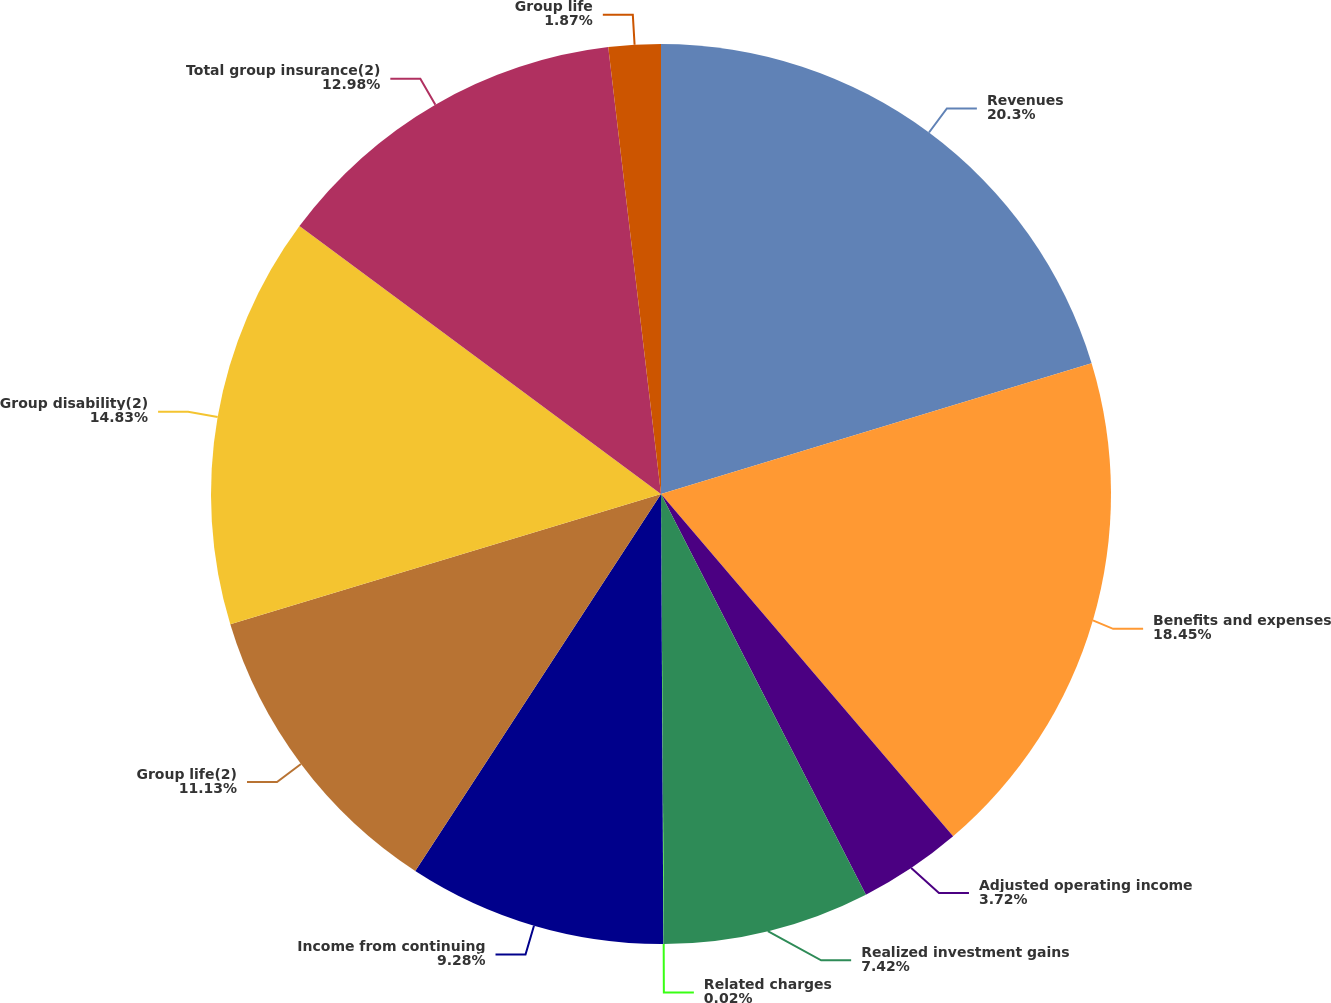Convert chart to OTSL. <chart><loc_0><loc_0><loc_500><loc_500><pie_chart><fcel>Revenues<fcel>Benefits and expenses<fcel>Adjusted operating income<fcel>Realized investment gains<fcel>Related charges<fcel>Income from continuing<fcel>Group life(2)<fcel>Group disability(2)<fcel>Total group insurance(2)<fcel>Group life<nl><fcel>20.31%<fcel>18.45%<fcel>3.72%<fcel>7.42%<fcel>0.02%<fcel>9.28%<fcel>11.13%<fcel>14.83%<fcel>12.98%<fcel>1.87%<nl></chart> 